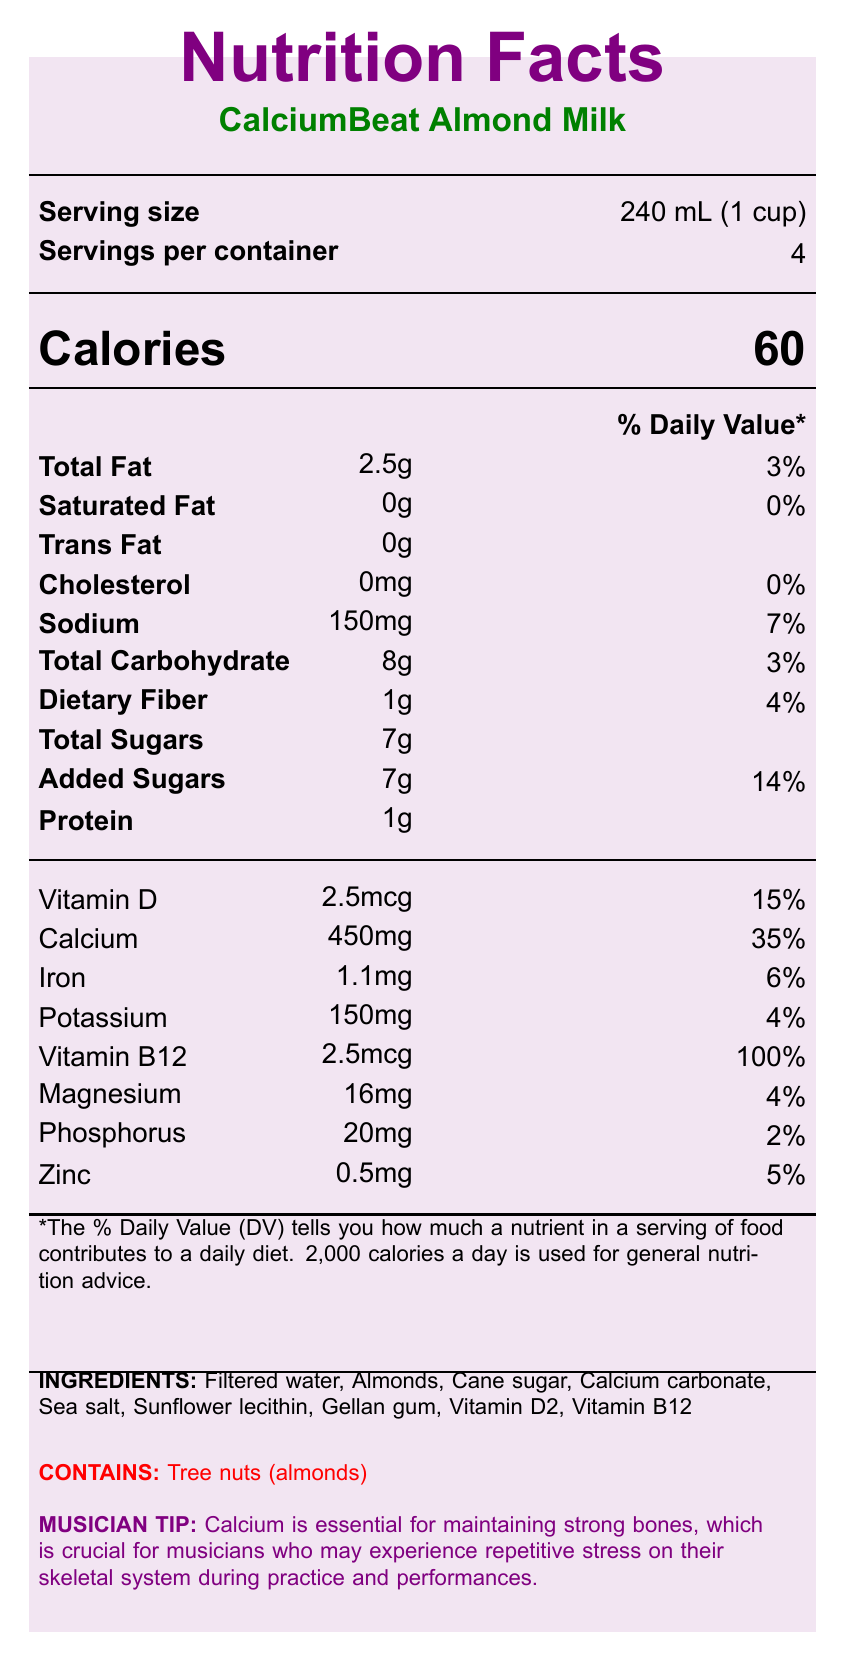what is the serving size? The document lists the serving size as "240 mL (1 cup)" under the serving information section.
Answer: 240 mL (1 cup) how many calories are in one serving? The document specifies that one serving contains 60 calories under the calorie information section.
Answer: 60 what is the total fat content per serving? The document mentions "Total Fat" as 2.5g in the nutrient information section.
Answer: 2.5g what percentage of the Daily Value is the sodium content? The document states that the sodium content is 150mg, which is 7% of the Daily Value.
Answer: 7% does this product contain any cholesterol? The document indicates that the cholesterol content is 0mg, which is 0% of the Daily Value.
Answer: No what is one potential allergen listed in the allergen information? The allergen information section clearly mentions that the product contains "Tree nuts (almonds)".
Answer: Tree nuts (almonds) which vitamin is present at 100% of the daily value? A. Vitamin D B. Vitamin B12 C. Vitamin C D. Iron The nutrient information section shows that Vitamin B12 is at 100% of the daily value (2.5mcg).
Answer: B. Vitamin B12 how should the product be stored after opening? A. Keep at room temperature B. Refrigerate C. Freeze D. Store in a dark place The storage instructions say to "Refrigerate after opening and consume within 7-10 days."
Answer: B. Refrigerate is this product suitable for vegans? The product claims section mentions that the product is "Dairy-free and vegan."
Answer: Yes what are some of the primary benefits of this product mentioned in the musician tip? The musician tip indicates that calcium is essential for maintaining strong bones, which is important for musicians to prevent repetitive stress during practice and performances.
Answer: Essential for maintaining strong bones, helps musicians prevent repetitive stress on their skeletal system describe the main idea of this document. The document aims to inform consumers about the nutritional value, ingredients, and benefits of "CalciumBeat Almond Milk," emphasizing its benefits for bone health, especially for musicians, and highlighting essential storage information.
Answer: The document provides detailed nutrition facts for "CalciumBeat Almond Milk," highlighting its nutrient content, ingredients, potential allergens, and storage instructions. It emphasizes the calcium-fortified nature of the product, making it suitable for strong bones and teeth, which is particularly beneficial for musicians. Additional claims include that it is dairy-free, vegan, and contains no artificial flavors or colors. which ingredient is a source of calcium in this product? The ingredients list includes "Calcium carbonate," which is typically used as a source of calcium in fortified foods.
Answer: Calcium carbonate what is the manufacturer's name? The document includes the manufacturer's name at the end of the ingredients and claims section.
Answer: HealthyHarmony Foods, Inc. what is the total carbohydrate content per serving? The document lists "Total Carbohydrate" as 8g in the nutrient information section.
Answer: 8g can we determine from the document how long the product has been on the market? The document does not provide any data regarding how long the product has been on the market.
Answer: Not enough information how much added sugar is in one serving? The document states "Added Sugars" as 7g, which is 14% of the Daily Value in the nutrient information section.
Answer: 7g 